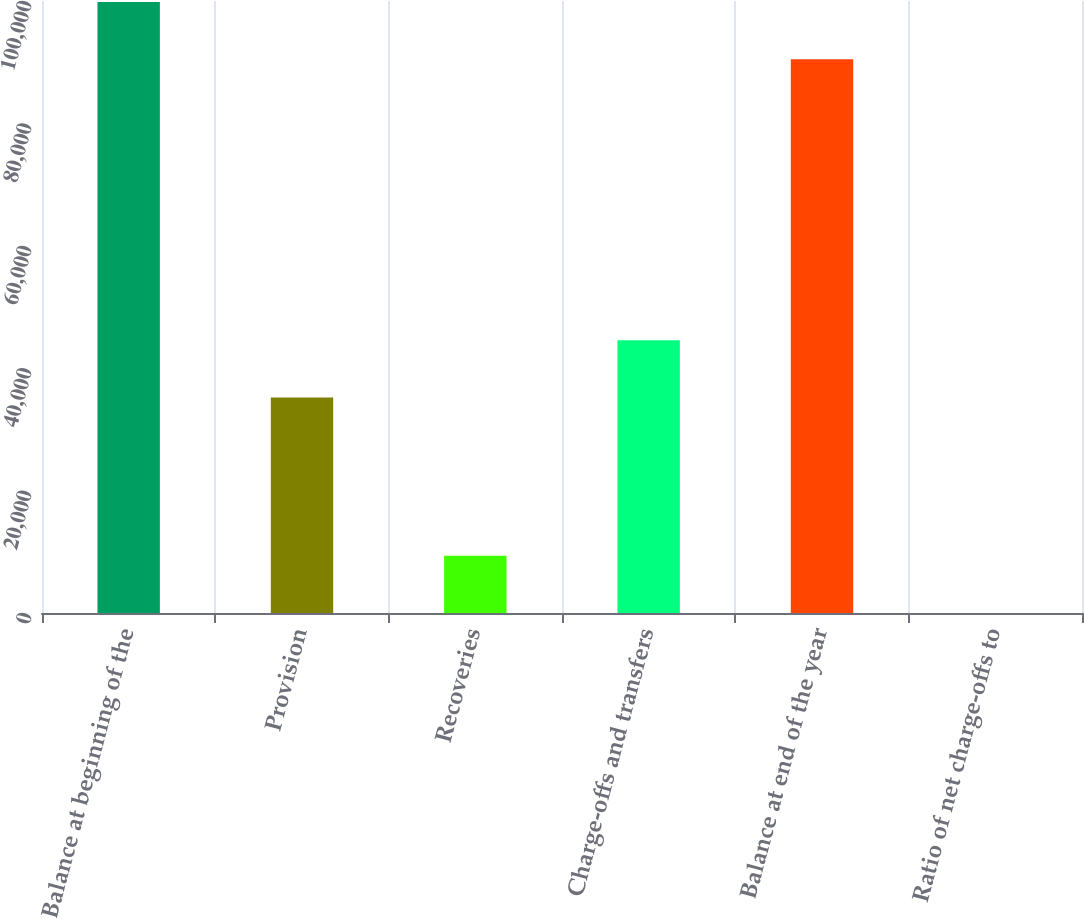Convert chart. <chart><loc_0><loc_0><loc_500><loc_500><bar_chart><fcel>Balance at beginning of the<fcel>Provision<fcel>Recoveries<fcel>Charge-offs and transfers<fcel>Balance at end of the year<fcel>Ratio of net charge-offs to<nl><fcel>99839.9<fcel>35200<fcel>9358.86<fcel>44552.9<fcel>90487<fcel>5.96<nl></chart> 